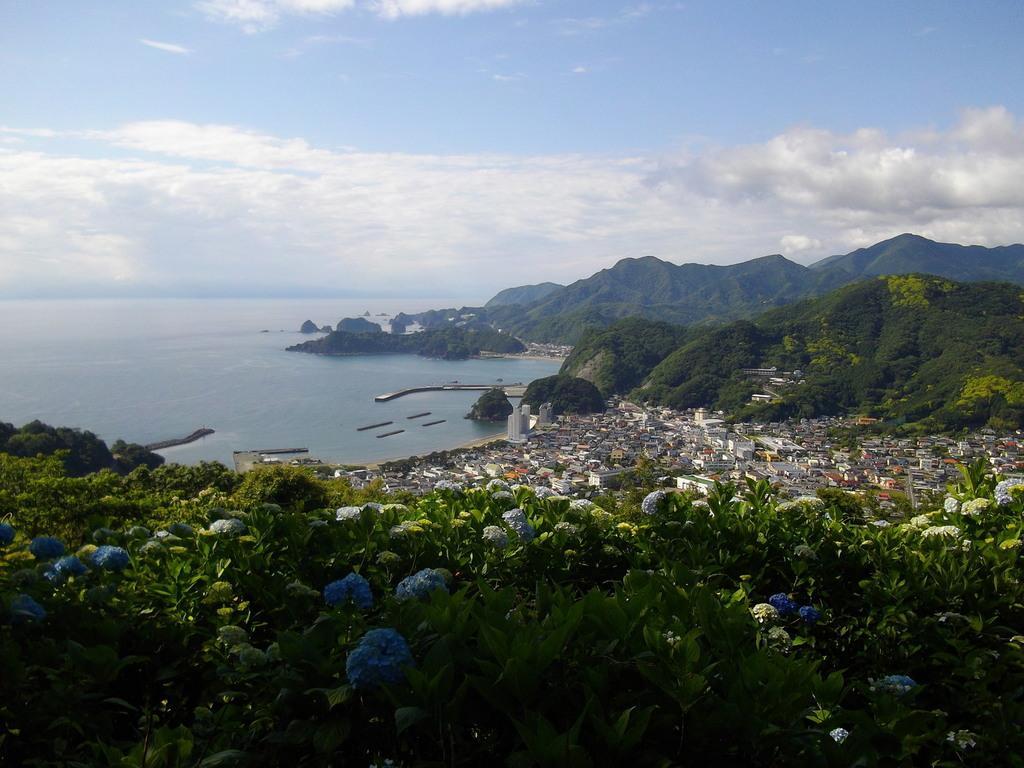Can you describe this image briefly? In this picture there are houses and trees at the bottom side of the image and there is water in the background area of the image. 